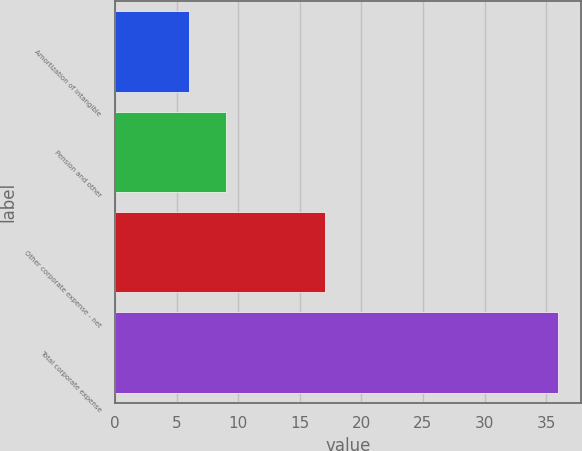<chart> <loc_0><loc_0><loc_500><loc_500><bar_chart><fcel>Amortization of intangible<fcel>Pension and other<fcel>Other corporate expense - net<fcel>Total corporate expense<nl><fcel>6<fcel>9<fcel>17<fcel>36<nl></chart> 